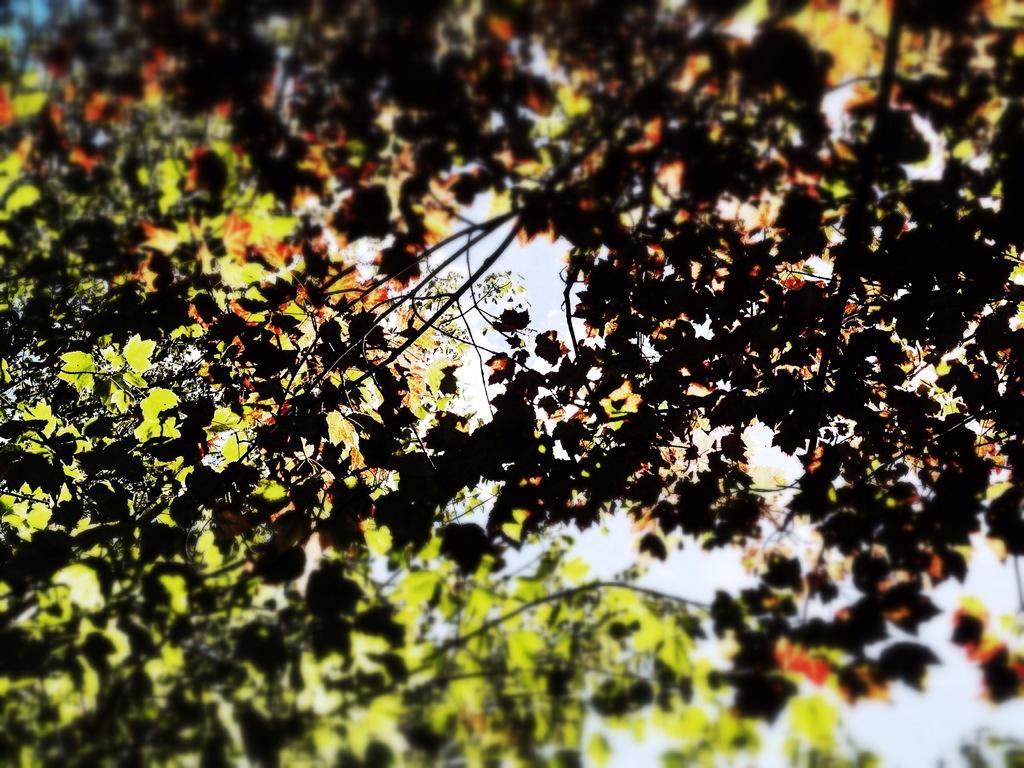Please provide a concise description of this image. This is a zoomed in picture. In the foreground we can see the leaves of a tree. In the background there is a sky. 